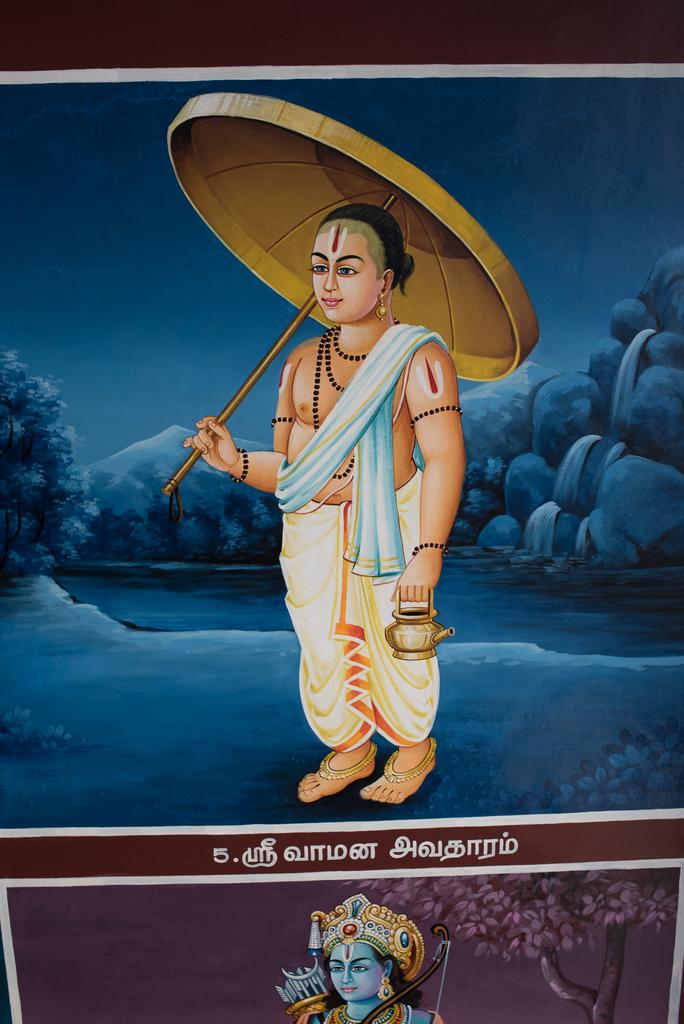What is the person in the image holding? The person is holding an umbrella and a bowl. What might the umbrella be used for in the image? The umbrella might be used for protection from rain or sun. What can be seen in the background of the image? There are trees, rocks, and the sky visible in the background of the image. What flavor of destruction can be seen in the image? There is no destruction present in the image, and therefore no flavor can be associated with it. 